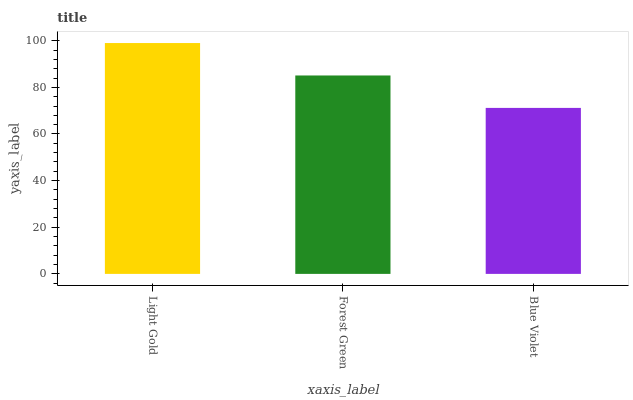Is Blue Violet the minimum?
Answer yes or no. Yes. Is Light Gold the maximum?
Answer yes or no. Yes. Is Forest Green the minimum?
Answer yes or no. No. Is Forest Green the maximum?
Answer yes or no. No. Is Light Gold greater than Forest Green?
Answer yes or no. Yes. Is Forest Green less than Light Gold?
Answer yes or no. Yes. Is Forest Green greater than Light Gold?
Answer yes or no. No. Is Light Gold less than Forest Green?
Answer yes or no. No. Is Forest Green the high median?
Answer yes or no. Yes. Is Forest Green the low median?
Answer yes or no. Yes. Is Light Gold the high median?
Answer yes or no. No. Is Blue Violet the low median?
Answer yes or no. No. 